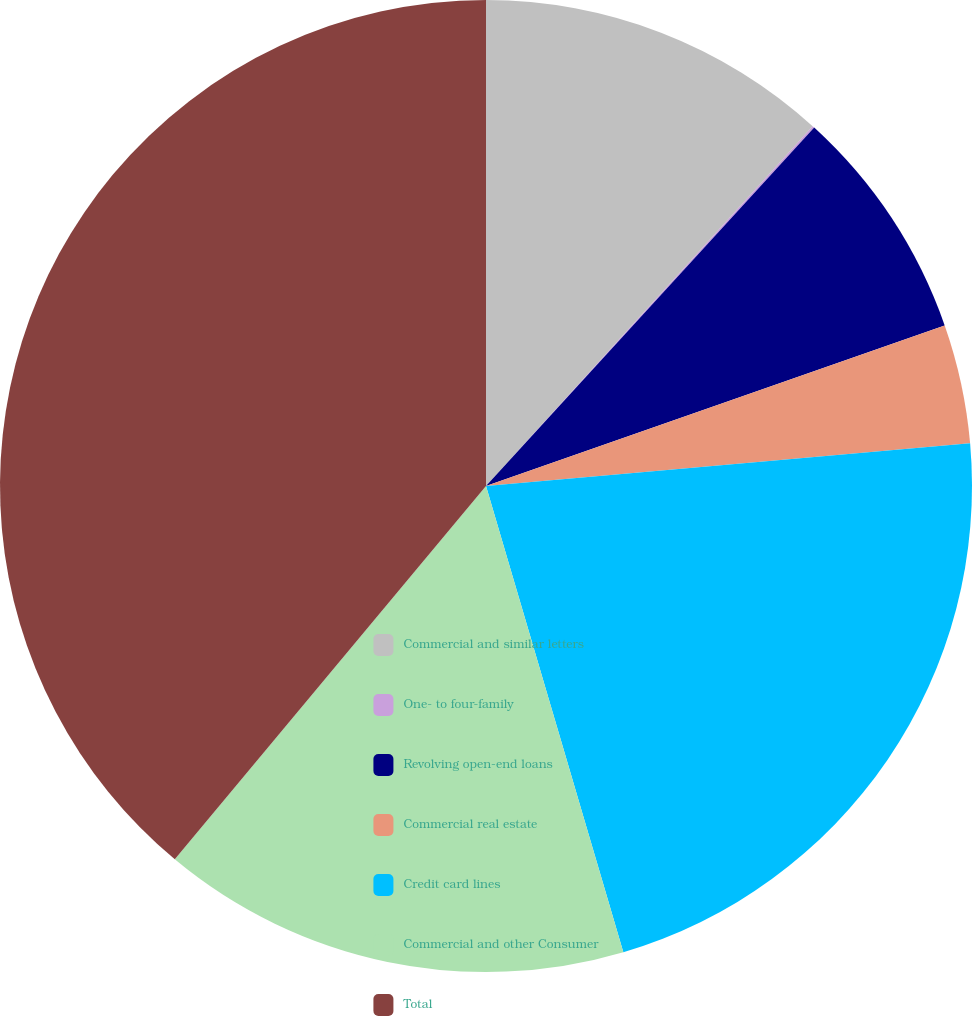Convert chart. <chart><loc_0><loc_0><loc_500><loc_500><pie_chart><fcel>Commercial and similar letters<fcel>One- to four-family<fcel>Revolving open-end loans<fcel>Commercial real estate<fcel>Credit card lines<fcel>Commercial and other Consumer<fcel>Total<nl><fcel>11.73%<fcel>0.07%<fcel>7.84%<fcel>3.96%<fcel>21.84%<fcel>15.62%<fcel>38.94%<nl></chart> 